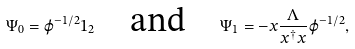<formula> <loc_0><loc_0><loc_500><loc_500>\Psi _ { 0 } = \varphi ^ { - 1 / 2 } 1 _ { 2 } \quad \text {and} \quad \Psi _ { 1 } = - x \frac { \Lambda } { x ^ { \dagger } x } \varphi ^ { - 1 / 2 } ,</formula> 